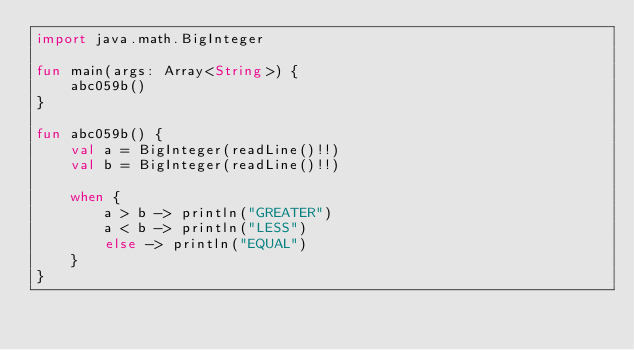Convert code to text. <code><loc_0><loc_0><loc_500><loc_500><_Kotlin_>import java.math.BigInteger

fun main(args: Array<String>) {
    abc059b()
}

fun abc059b() {
    val a = BigInteger(readLine()!!)
    val b = BigInteger(readLine()!!)

    when {
        a > b -> println("GREATER")
        a < b -> println("LESS")
        else -> println("EQUAL")
    }
}
</code> 